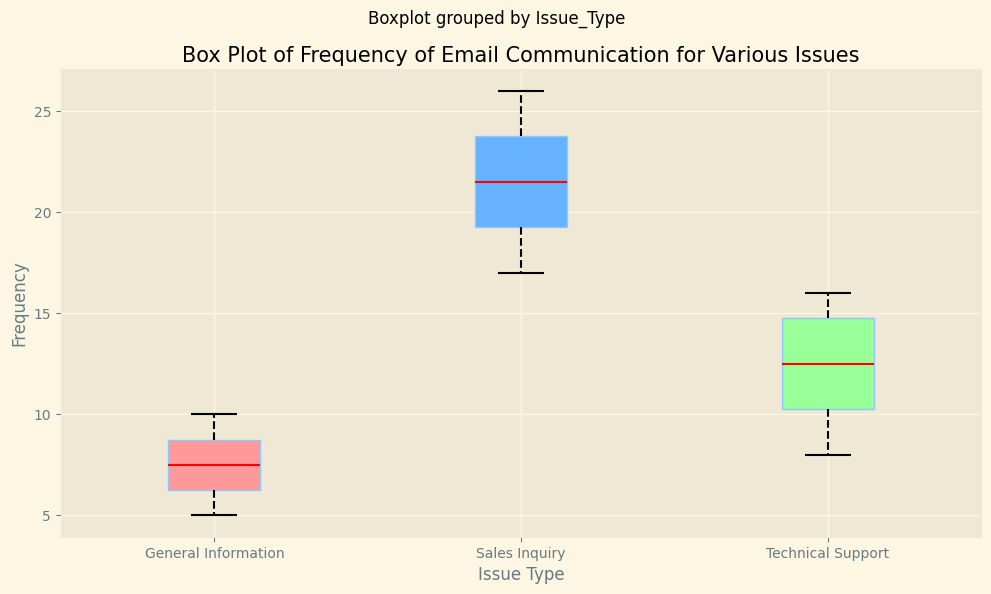How many emails were sent in total for Technical Support? The frequency of emails sent for Technical Support is provided as a list: [10, 15, 11, 9, 13, 8, 16, 12, 15, 14]. Summing these values gives: 10 + 15 + 11 + 9 + 13 + 8 + 16 + 12 + 15 + 14 = 123.
Answer: 123 Which issue type has the highest median email frequency? The box plot shows the medians for each issue type. For Technical Support, Sales Inquiry, and General Information, the medians are 12.5, 22, and 7 respectively. The highest median is 22 for Sales Inquiry.
Answer: Sales Inquiry What is the range of email frequencies for General Information? The range is the difference between the maximum and minimum values. For General Information, the minimum is 5 and the maximum is 10. Hence, the range is 10 - 5 = 5.
Answer: 5 How does the interquartile range (IQR) of Sales Inquiry compare to that of Technical Support? The IQR is the difference between Q3 and Q1 (the third and first quartiles). From the box plot, Sales Inquiry has Q1 at 19.5 and Q3 at 23.5, so its IQR is 23.5 - 19.5 = 4. Technical Support has Q1 at 10 and Q3 at 15, so its IQR is 15 - 10 = 5. Therefore, Sales Inquiry's IQR is 1 unit less than that of Technical Support.
Answer: Sales Inquiry's IQR is 1 unit less What is the most frequent range of emails sent for Sales Inquiry? The box plot indicates that the majority of data points (75%) fall within the interquartile range (IQR). For Sales Inquiry, this range is from Q1 (19.5) to Q3 (23.5). Therefore, the most frequent range of emails is within 19.5 to 23.5.
Answer: 19.5 to 23.5 How many outliers are there in the data? Outliers are represented by points beyond the whiskers in a box plot. For all issue types combined, we observe no individual data points plotted beyond the whiskers for any of the categories in the visual. So, there are no outliers in the data.
Answer: 0 What is the median email frequency for General Information, and how does it compare to that of Technical Support? The median for General Information is 7, and for Technical Support, it is 12.5. General Information has a lower median compared to Technical Support by 12.5 - 7 = 5.5 units.
Answer: 7, 5.5 units lower Which issue type has more variation in email frequency? Variation can be visually assessed by the spread of the box and whiskers. General Information and Sales Inquiry both have similar whisker lengths, but the box for General Information (IQR) is shorter. Technical Support has a relatively wider IQR and whiskers combined. Thus, Technical Support has the most variation in email frequency.
Answer: Technical Support Which issue type has the lowest median email frequency? Observing the medians on the box plot, General Information has the lowest median value of 7 compared to Sales Inquiry (22) and Technical Support (12.5).
Answer: General Information 